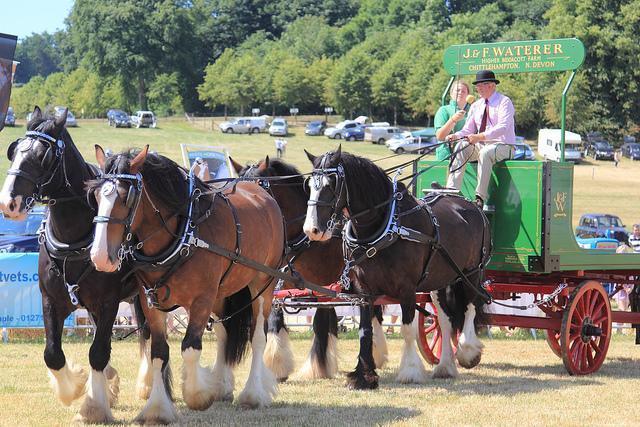How many horses are in the photo?
Give a very brief answer. 4. How many horses are there?
Give a very brief answer. 4. 